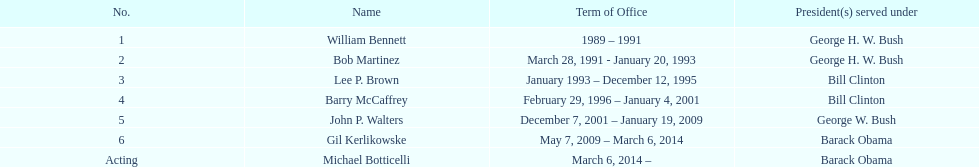How many directors maintained their position for over three years? 3. 